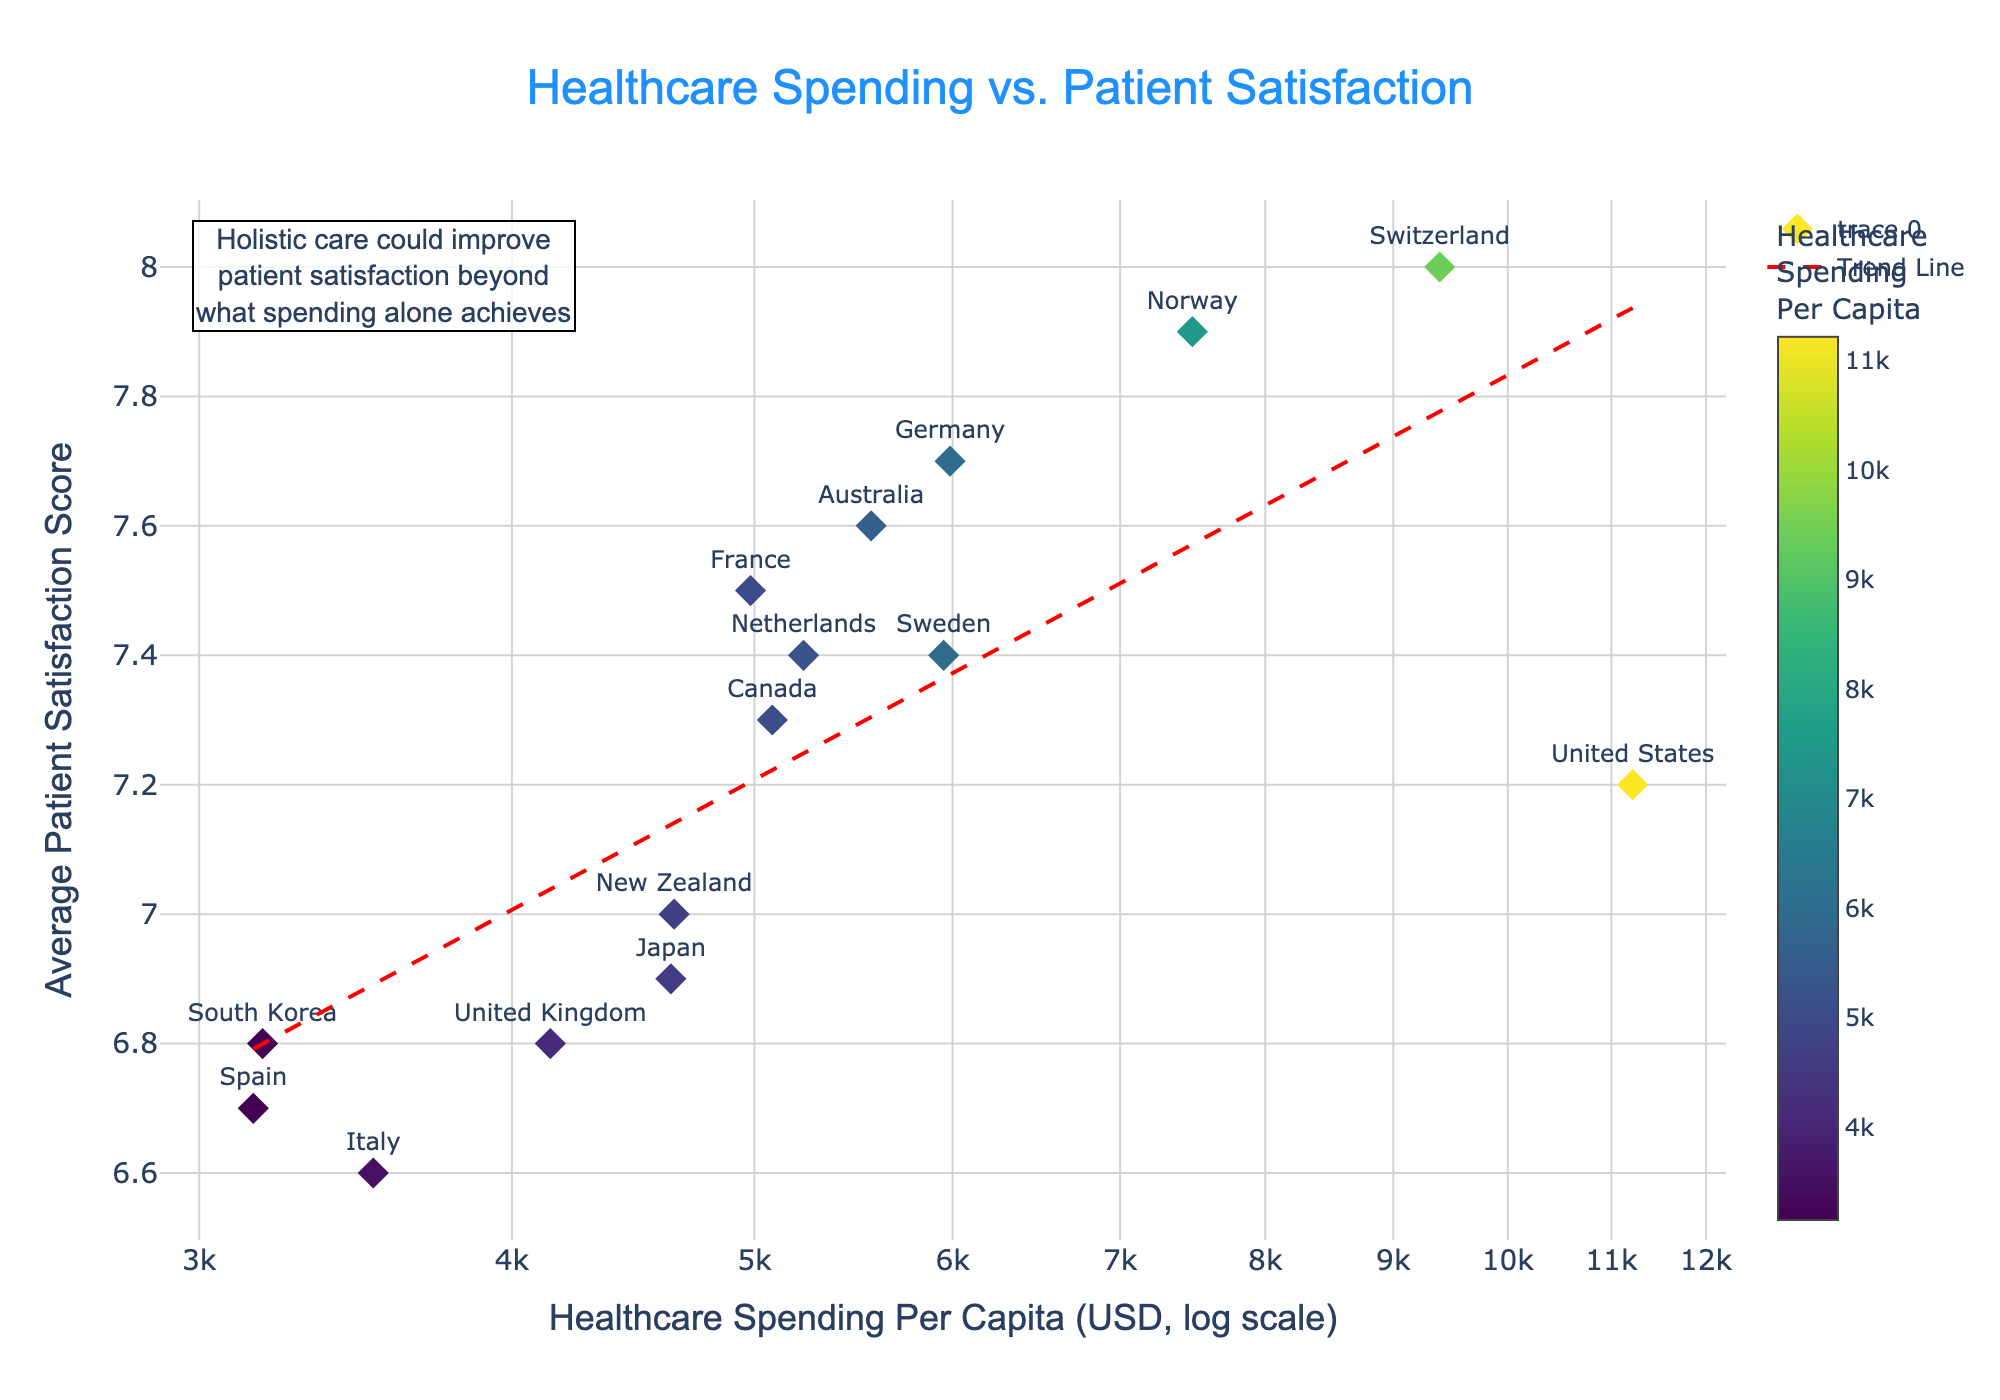Which country has the highest average patient satisfaction score? From the figure, identify the point with the highest position on the y-axis and the corresponding country label.
Answer: Switzerland What is the approximate healthcare spending per capita for Spain? Locate Spain's label on the figure, then reference its position on the x-axis, noting the logarithmic scale.
Answer: 3153 USD How many countries have an average patient satisfaction score greater than 7.5? Count the number of data points above the y-axis value of 7.5.
Answer: 4 Which country has the lowest healthcare spending per capita? Find the point furthest left on the x-axis and identify its country label.
Answer: Spain Do countries with higher healthcare spending always have higher patient satisfaction? Observe the scatter of points and analyze if every higher x-value consistently corresponds to a higher y-value.
Answer: No What trend is indicated by the trend line? Determine the general direction of the dashed red line (upward or downward), indicating a relationship between x and y values.
Answer: Upward trend What is the approximate healthcare spending per capita for countries with a patient satisfaction score around 7.0? Identify the data points near the y-value of 7.0 and note their positions on the x-axis.
Answer: 4644-5083 USD Is the United States' patient satisfaction score above or below the trend line? Compare the United States' data point (label) position relative to the red dashed trend line.
Answer: Below What conclusion does the annotation suggest regarding holistic care? Read the annotation text provided near the top left of the figure.
Answer: Holistic care could improve patient satisfaction beyond spending Which country is shown as a diamond symbol with the lowest average patient satisfaction score? Identify the data point furthest down on the y-axis and specify its country label.
Answer: Italy 